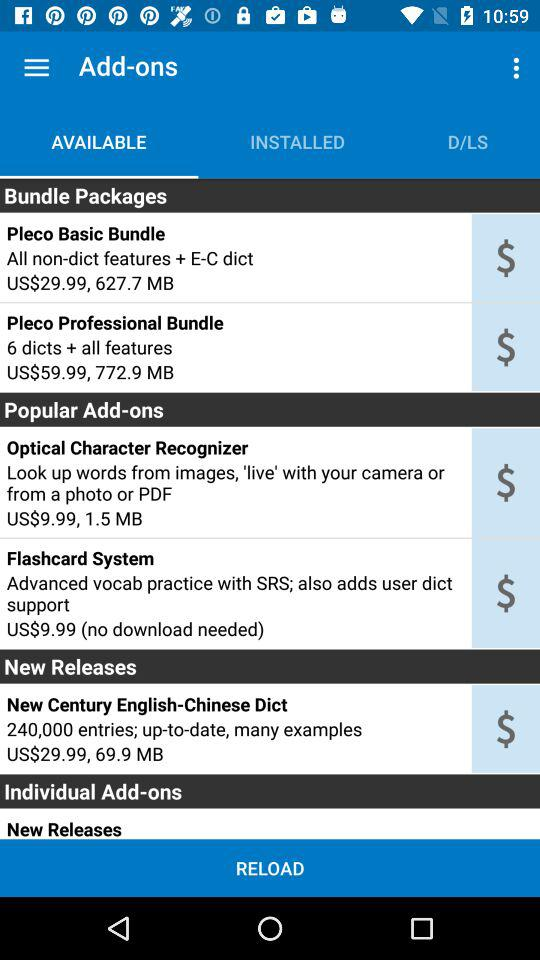Which tab is selected? The selected tab is "AVAILABLE". 